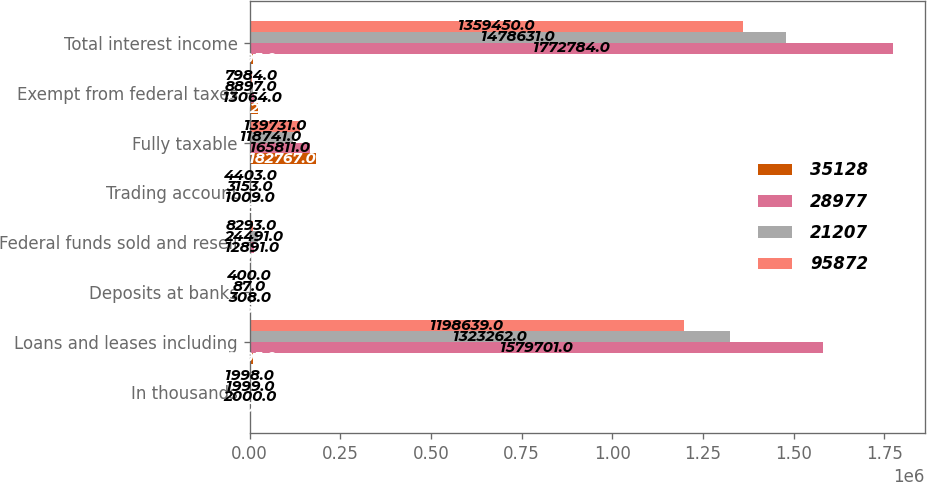Convert chart. <chart><loc_0><loc_0><loc_500><loc_500><stacked_bar_chart><ecel><fcel>In thousands<fcel>Loans and leases including<fcel>Deposits at banks<fcel>Federal funds sold and resell<fcel>Trading account<fcel>Fully taxable<fcel>Exempt from federal taxes<fcel>Total interest income<nl><fcel>35128<fcel>2001<fcel>8595<fcel>116<fcel>2027<fcel>348<fcel>182767<fcel>24120<fcel>8595<nl><fcel>28977<fcel>2000<fcel>1.5797e+06<fcel>308<fcel>12891<fcel>1009<fcel>165811<fcel>13064<fcel>1.77278e+06<nl><fcel>21207<fcel>1999<fcel>1.32326e+06<fcel>87<fcel>24491<fcel>3153<fcel>118741<fcel>8897<fcel>1.47863e+06<nl><fcel>95872<fcel>1998<fcel>1.19864e+06<fcel>400<fcel>8293<fcel>4403<fcel>139731<fcel>7984<fcel>1.35945e+06<nl></chart> 